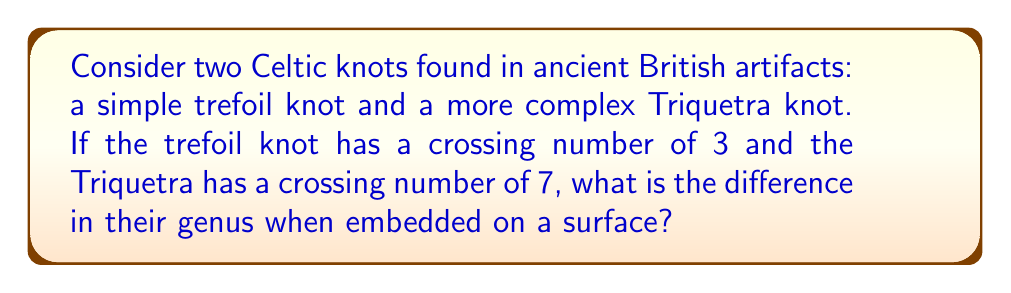Solve this math problem. To solve this problem, we'll follow these steps:

1. Recall the relationship between crossing number and genus for alternating knots:
   $$g = \frac{c - n + 2}{2}$$
   where $g$ is the genus, $c$ is the crossing number, and $n$ is the number of components (1 for both knots in this case).

2. For the trefoil knot:
   $$g_1 = \frac{3 - 1 + 2}{2} = \frac{4}{2} = 2$$

3. For the Triquetra knot:
   $$g_2 = \frac{7 - 1 + 2}{2} = \frac{8}{2} = 4$$

4. Calculate the difference in genus:
   $$\text{Difference} = g_2 - g_1 = 4 - 2 = 2$$

This difference in genus reflects the increased complexity of the Triquetra knot compared to the simpler trefoil knot, which would be relevant to understanding the evolution of artistic and symbolic representations in ancient British artifacts.
Answer: 2 